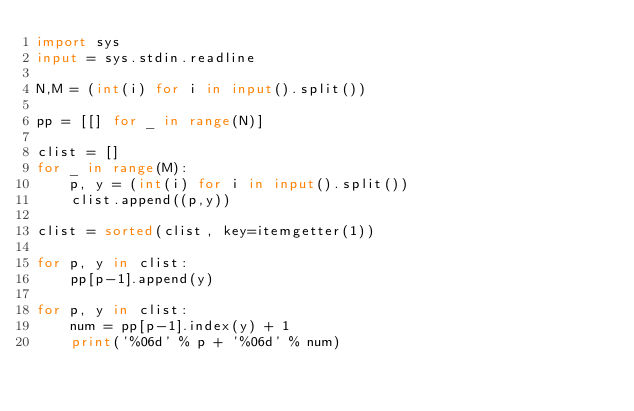<code> <loc_0><loc_0><loc_500><loc_500><_Python_>import sys
input = sys.stdin.readline

N,M = (int(i) for i in input().split())

pp = [[] for _ in range(N)]

clist = []
for _ in range(M):
    p, y = (int(i) for i in input().split())
    clist.append((p,y))

clist = sorted(clist, key=itemgetter(1))

for p, y in clist:
    pp[p-1].append(y)

for p, y in clist:
    num = pp[p-1].index(y) + 1
    print('%06d' % p + '%06d' % num)</code> 